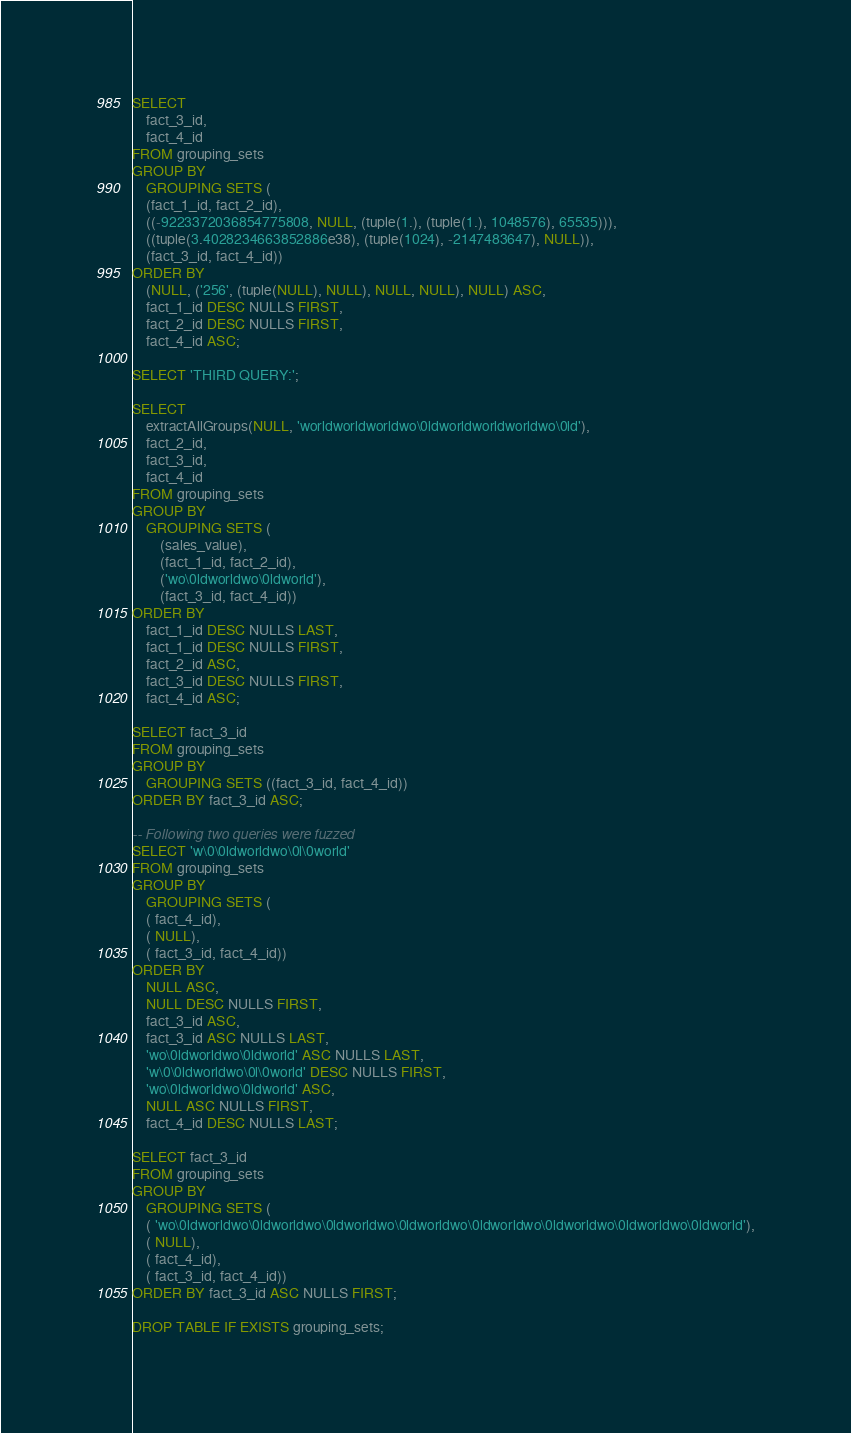<code> <loc_0><loc_0><loc_500><loc_500><_SQL_>SELECT
    fact_3_id,
    fact_4_id
FROM grouping_sets
GROUP BY
    GROUPING SETS (
    (fact_1_id, fact_2_id),
    ((-9223372036854775808, NULL, (tuple(1.), (tuple(1.), 1048576), 65535))),
    ((tuple(3.4028234663852886e38), (tuple(1024), -2147483647), NULL)),
    (fact_3_id, fact_4_id))
ORDER BY
    (NULL, ('256', (tuple(NULL), NULL), NULL, NULL), NULL) ASC,
    fact_1_id DESC NULLS FIRST,
    fact_2_id DESC NULLS FIRST,
    fact_4_id ASC;

SELECT 'THIRD QUERY:';

SELECT
    extractAllGroups(NULL, 'worldworldworldwo\0ldworldworldworldwo\0ld'),
    fact_2_id,
    fact_3_id,
    fact_4_id
FROM grouping_sets
GROUP BY
    GROUPING SETS (
        (sales_value),
        (fact_1_id, fact_2_id),
        ('wo\0ldworldwo\0ldworld'),
        (fact_3_id, fact_4_id))
ORDER BY
    fact_1_id DESC NULLS LAST,
    fact_1_id DESC NULLS FIRST,
    fact_2_id ASC,
    fact_3_id DESC NULLS FIRST,
    fact_4_id ASC;

SELECT fact_3_id
FROM grouping_sets
GROUP BY
    GROUPING SETS ((fact_3_id, fact_4_id))
ORDER BY fact_3_id ASC;

-- Following two queries were fuzzed
SELECT 'w\0\0ldworldwo\0l\0world'
FROM grouping_sets
GROUP BY
    GROUPING SETS (
    ( fact_4_id),
    ( NULL),
    ( fact_3_id, fact_4_id))
ORDER BY
    NULL ASC,
    NULL DESC NULLS FIRST,
    fact_3_id ASC,
    fact_3_id ASC NULLS LAST,
    'wo\0ldworldwo\0ldworld' ASC NULLS LAST,
    'w\0\0ldworldwo\0l\0world' DESC NULLS FIRST,
    'wo\0ldworldwo\0ldworld' ASC,
    NULL ASC NULLS FIRST,
    fact_4_id DESC NULLS LAST;

SELECT fact_3_id
FROM grouping_sets
GROUP BY
    GROUPING SETS (
    ( 'wo\0ldworldwo\0ldworldwo\0ldworldwo\0ldworldwo\0ldworldwo\0ldworldwo\0ldworldwo\0ldworld'),
    ( NULL),
    ( fact_4_id),
    ( fact_3_id, fact_4_id))
ORDER BY fact_3_id ASC NULLS FIRST;

DROP TABLE IF EXISTS grouping_sets;</code> 